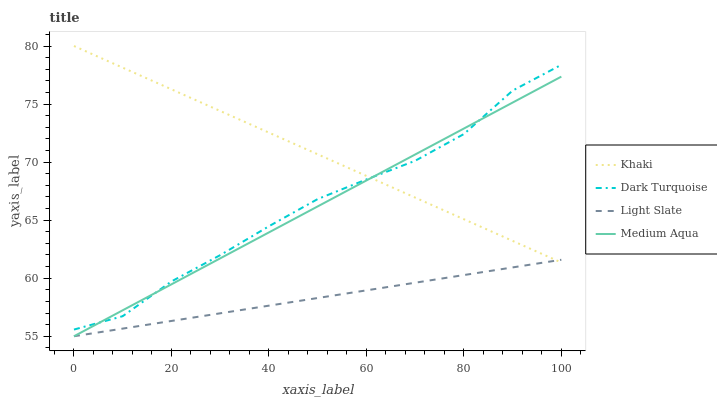Does Dark Turquoise have the minimum area under the curve?
Answer yes or no. No. Does Dark Turquoise have the maximum area under the curve?
Answer yes or no. No. Is Khaki the smoothest?
Answer yes or no. No. Is Khaki the roughest?
Answer yes or no. No. Does Dark Turquoise have the lowest value?
Answer yes or no. No. Does Dark Turquoise have the highest value?
Answer yes or no. No. Is Light Slate less than Dark Turquoise?
Answer yes or no. Yes. Is Dark Turquoise greater than Light Slate?
Answer yes or no. Yes. Does Light Slate intersect Dark Turquoise?
Answer yes or no. No. 